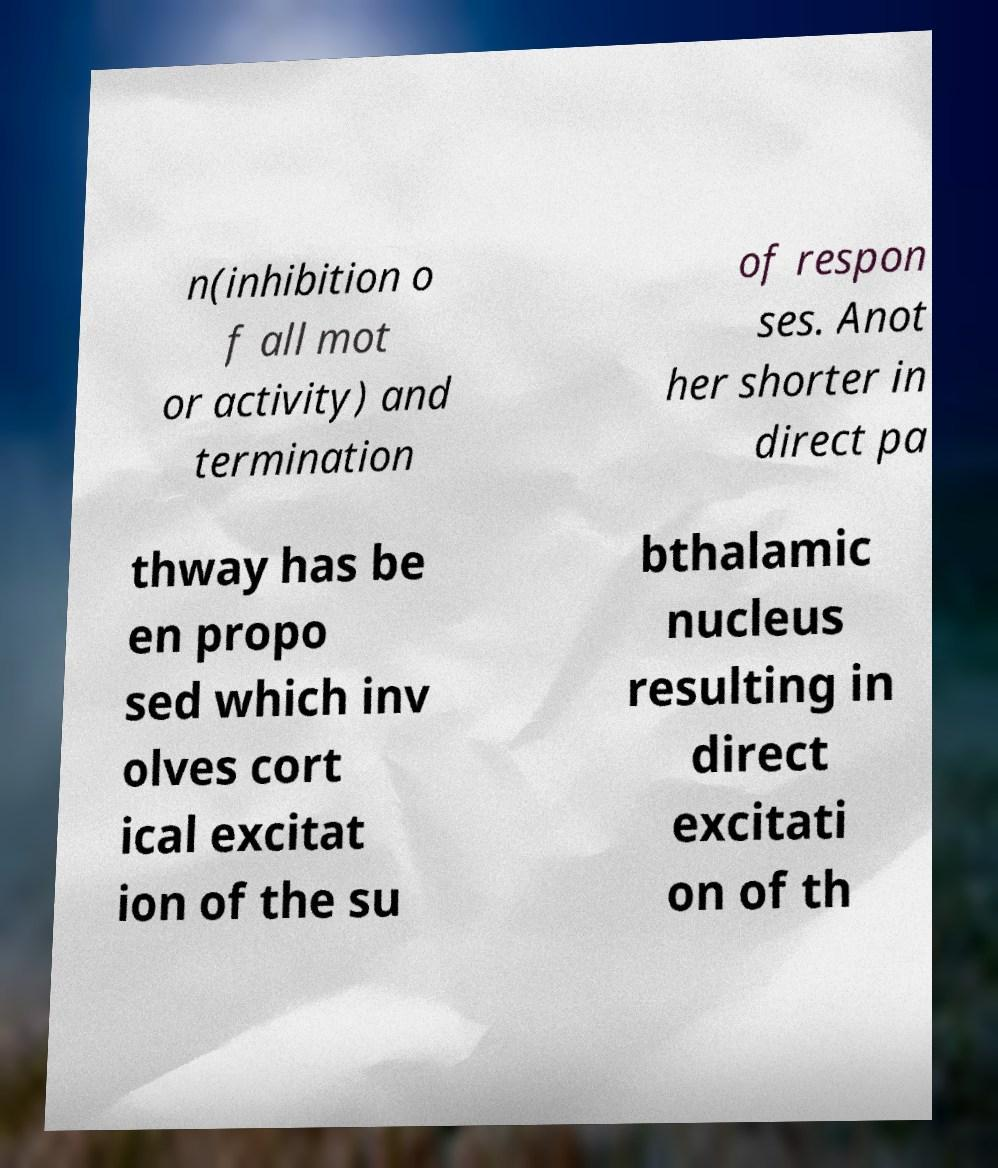What messages or text are displayed in this image? I need them in a readable, typed format. n(inhibition o f all mot or activity) and termination of respon ses. Anot her shorter in direct pa thway has be en propo sed which inv olves cort ical excitat ion of the su bthalamic nucleus resulting in direct excitati on of th 